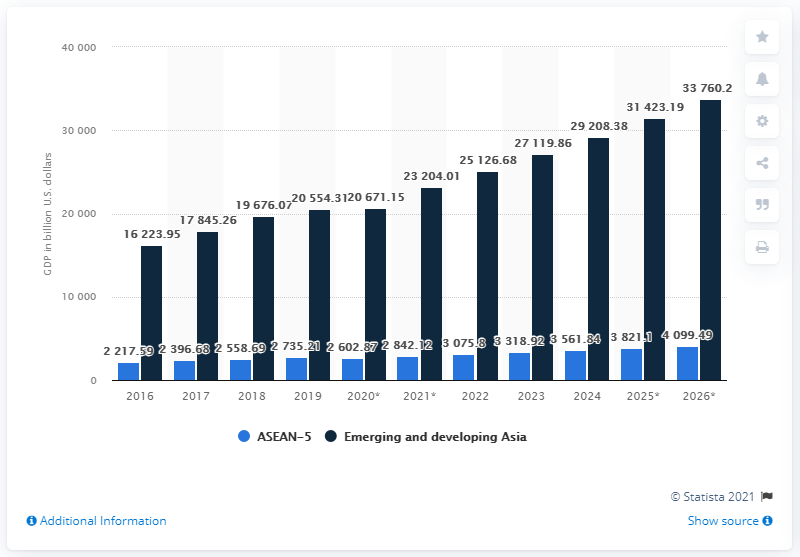Highlight a few significant elements in this photo. According to estimates, the GDP of emerging and developing countries in Asia is expected to reach 33,760.27 by 2026. In the previous decade, the GDP of emerging and developing countries was 16,223.95... 